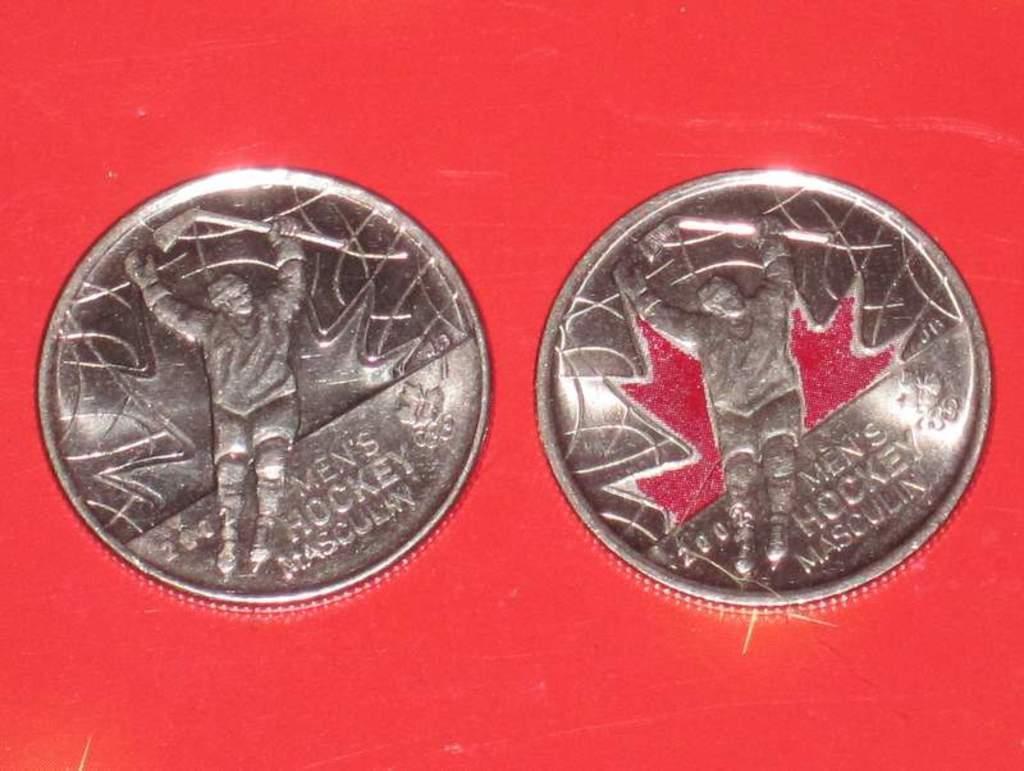Could you give a brief overview of what you see in this image? In this picture, it seems like coins on the red background, on which there is a depiction and text. 